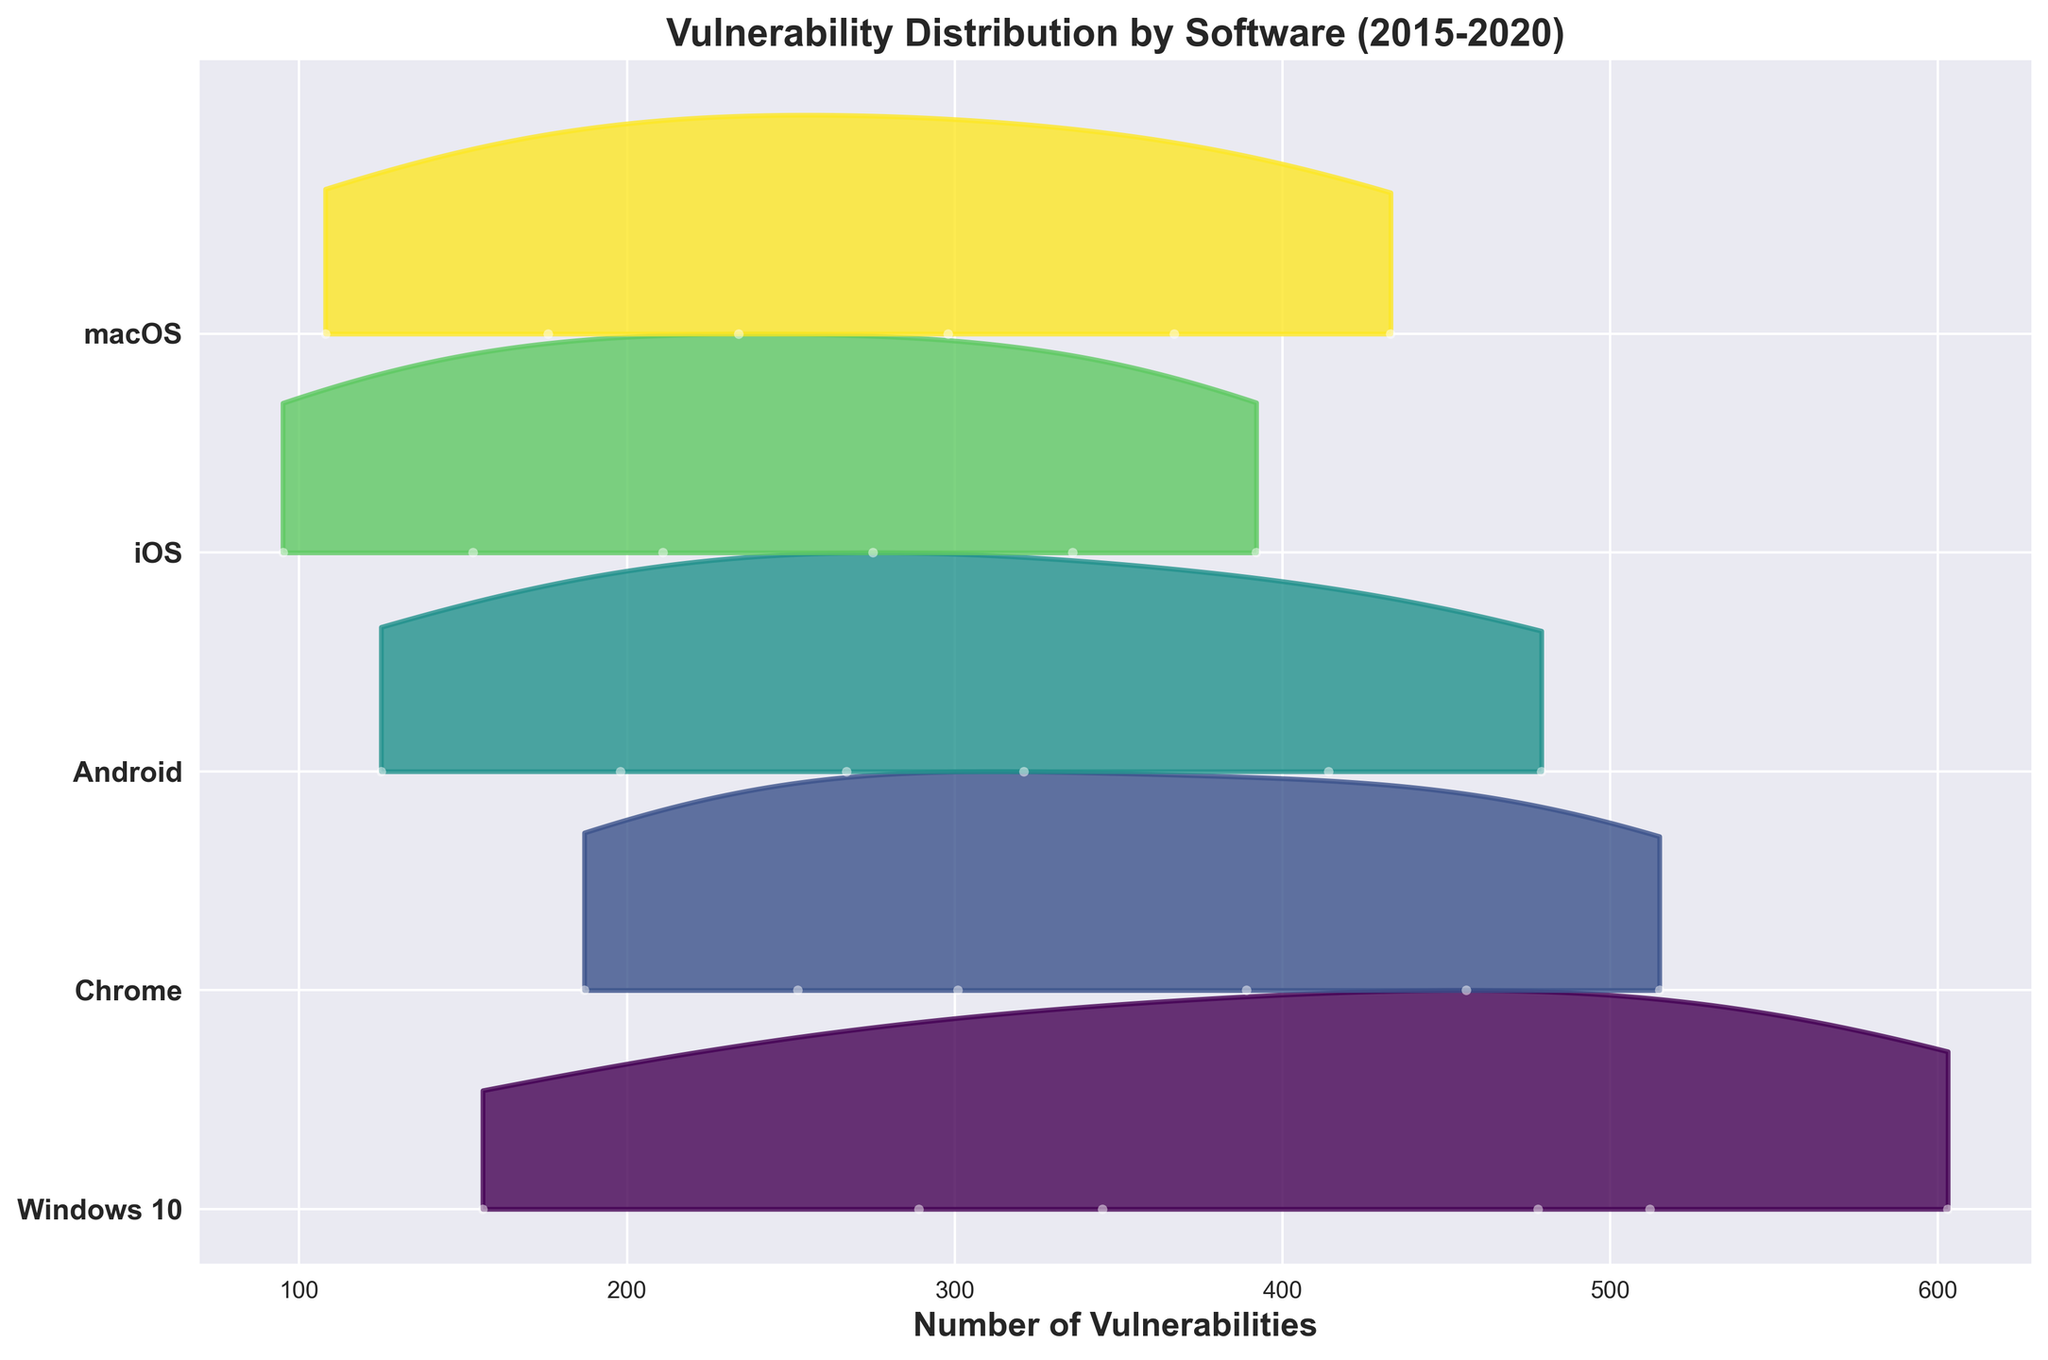what's the title of the figure? You can see the title at the top of the plot, which reads "Vulnerability Distribution by Software (2015-2020)"
Answer: Vulnerability Distribution by Software (2015-2020) how many software categories are shown in the plot? The number of different software labels on the y-axis corresponds to the number of categories.
Answer: 5 which software category has the highest number of vulnerabilities in 2020? By observing the right end of the plot where the color bands and data points peak, Windows 10 has the highest number of vulnerabilities near the upper end.
Answer: Windows 10 compare the spread of vulnerabilities between Android and iOS in 2019 Look at the width and shape of the color bands for Android and iOS in 2019. Android's distribution for vulnerabilities is wider, indicating a higher number of vulnerabilities compared to iOS.
Answer: Android has a higher spread which year's vulnerabilities have the smallest range for macOS? Look for the macOS color bands and compare the width across different years. The narrowest band indicates the smallest range.
Answer: 2015 how do the vulnerabilities in Chrome from 2015 to 2016 compare? Observe the position of Chrome's points for 2015 and 2016 on the plot. The height difference between the two years suggests an increase.
Answer: Increased which software shows the most consistent increase in vulnerabilities over the years? By looking at the consistent upward trends across the years, Windows 10 shows a steady increase in vulnerabilities each year.
Answer: Windows 10 is there a year where Android and iOS have similar vulnerabilities? Compare the points for Android and iOS across all years. In 2020, their points are relatively close, indicating similar vulnerabilities.
Answer: 2020 estimate the median number of vulnerabilities for Windows 10 over the years The median number can be approximated by locating the middle value of the vulnerabilities over all years for Windows 10, which visually appears around mid-range in the KDE-filled area.
Answer: Approximately 400 which software category exhibits the widest distribution of vulnerabilities in 2017? Compare the spread of the colored regions for each category in 2017. The widest distribution is visually identifiable as Windows 10.
Answer: Windows 10 